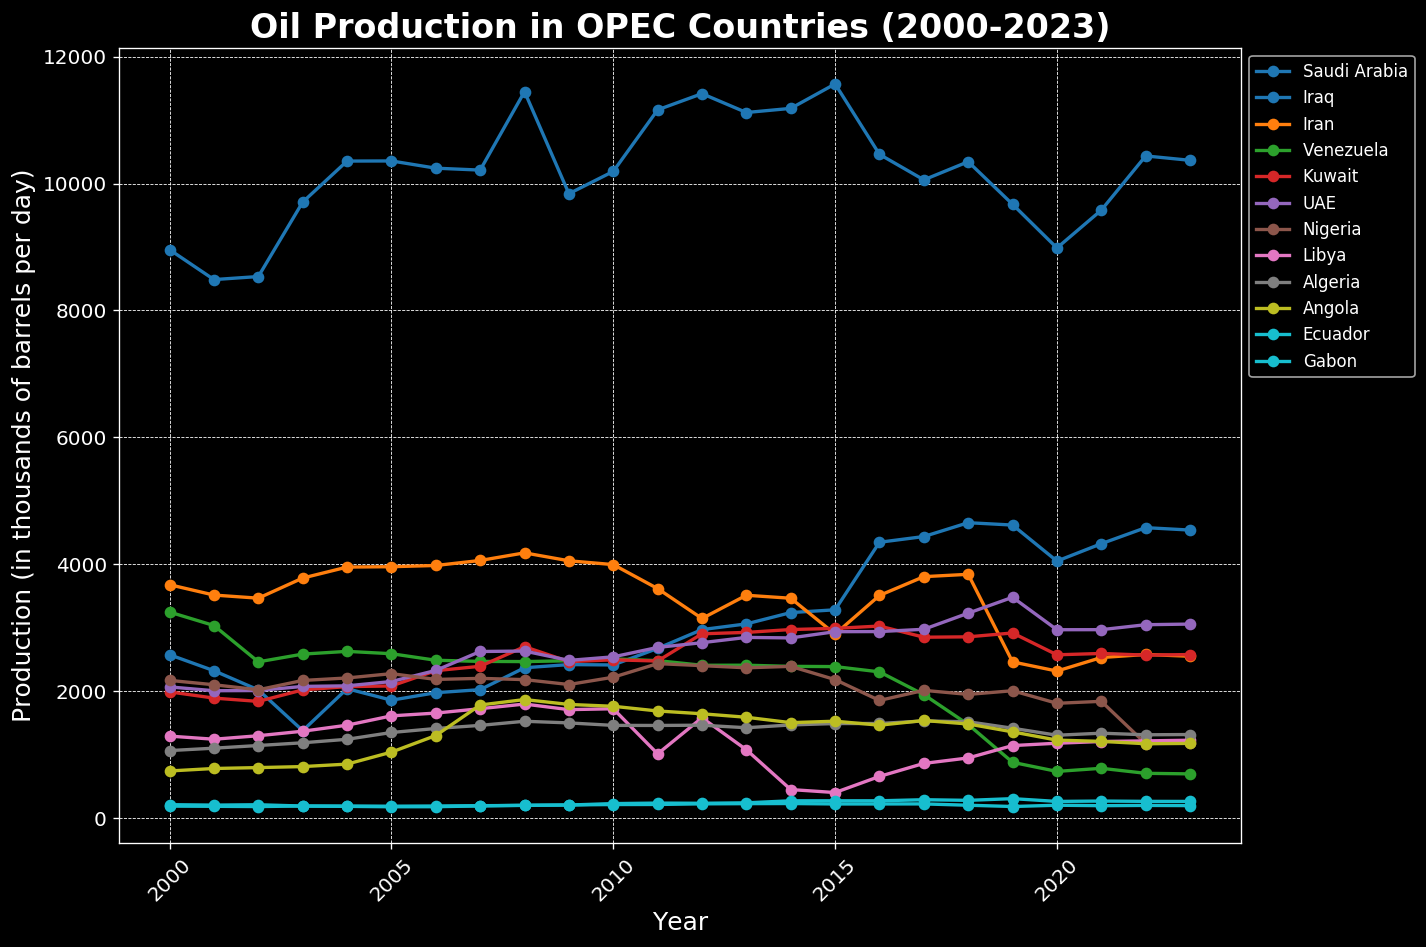Which country had the highest oil production in 2023? Look at the data points in the figure for 2023 and identify the highest line. The highest line represents Saudi Arabia's production.
Answer: Saudi Arabia How did oil production in Venezuela change from 2000 to 2023? Compare the 2000 data point for Venezuela with the 2023 data point. Note that Venezuela's production dropped significantly from around 3249 thousand barrels per day in 2000 to around 700 thousand barrels per day in 2023.
Answer: Decreased significantly Which country experienced the largest increase in oil production between 2000 and 2023? Compare the oil production values for each country for 2000 and 2023. Calculate the difference and find the maximum increase. Iraq shows the largest increase, moving from approximately 2577 in 2000 to 4541 in 2023.
Answer: Iraq In which year did Libya have the lowest oil production? Identify the lowest point on Libya’s line in the figure. Libya had the lowest production around 2014.
Answer: 2014 Compare the oil production trends of Saudi Arabia and Iran from 2000 to 2023. Observe the lines representing Saudi Arabia and Iran. Saudi Arabia's production shows an overall rise with fluctuations, while Iran's production has been relatively stable with a significant drop around 2012. Both lines’ slopes and general trends can be noted for comparison.
Answer: Saudi Arabia increased overall, Iran was stable but dropped around 2012 What was the approximate difference in oil production between Saudi Arabia and Nigeria in 2023? Locate the points on the graph for Saudi Arabia and Nigeria in 2023. Subtract Nigeria's production from Saudi Arabia's production. Approximately 10366 - 1190 = 9176 thousand barrels per day.
Answer: 9176 thousand barrels per day Which countries had a consistent increase in oil production from 2000 to 2023? Look for lines with a continuous upward trend from 2000 to 2023. Countries like Iraq and UAE show a consistent increase over the entire period.
Answer: Iraq, UAE How did the oil production in Nigeria change from 2008 to 2011? Identify the points for Nigeria in 2008 and 2011. Nigeria's production rose from approximately 2185 in 2008 to 2437 in 2011.
Answer: Increased Between which years did Saudi Arabia's oil production peak? Look for Saudi Arabia's peak point in the figure; it appears around 2008 and 2012-2015. These peaks should be noted for the specific years.
Answer: 2008, 2012-2015 What is the visual difference in the change of production trends of Saudi Arabia and Venezuela from 2010 to 2020? Observe the trends between these years for both countries. Saudi Arabia’s line fluctuates but remains relatively high, while Venezuela's line shows a steep drop.
Answer: Saudi Arabia fluctuates, Venezuela drops steeply 